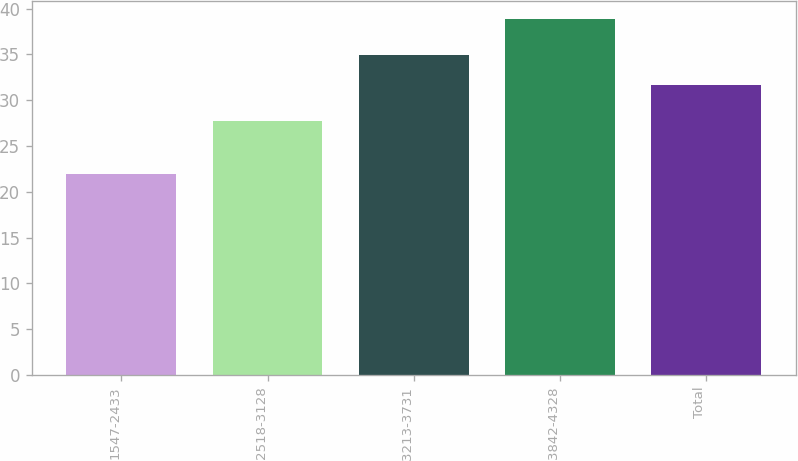<chart> <loc_0><loc_0><loc_500><loc_500><bar_chart><fcel>1547-2433<fcel>2518-3128<fcel>3213-3731<fcel>3842-4328<fcel>Total<nl><fcel>21.95<fcel>27.72<fcel>34.97<fcel>38.9<fcel>31.69<nl></chart> 